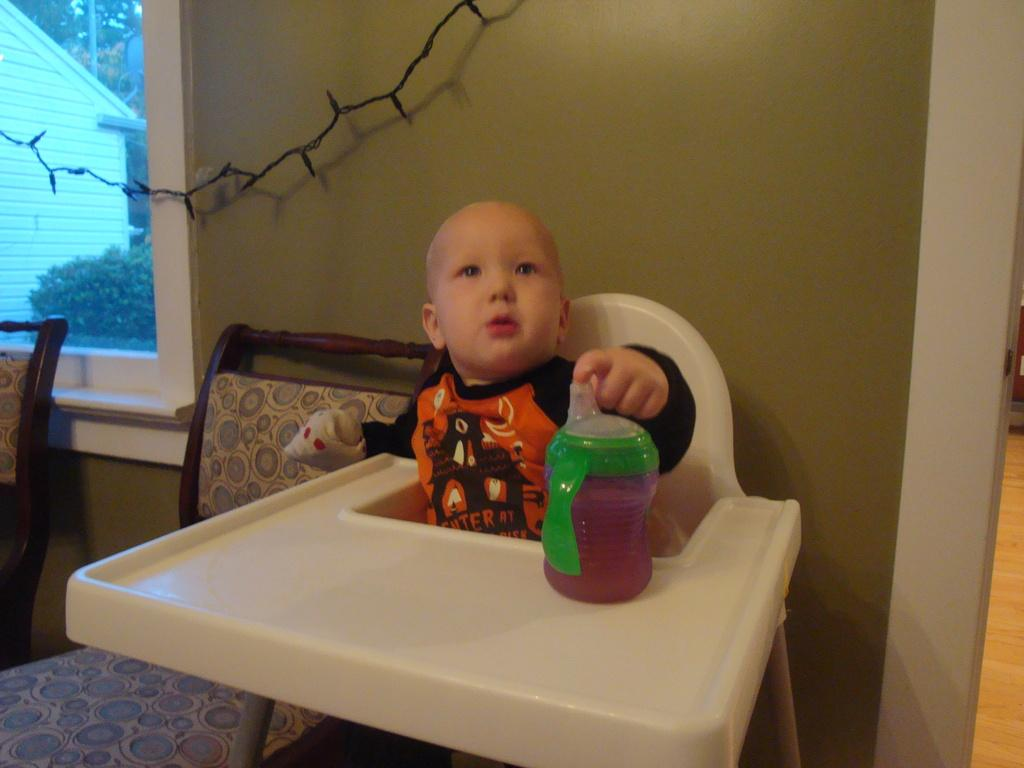What is the baby doing in the image? The baby is sitting on a chair in the image. What is in front of the baby? There is a bottle in front of the baby. What can be seen through the window in the room? Plants and a house are visible outside the window. How many chairs are beside the baby? There are 2 chairs beside the baby. What type of police wing is visible outside the window? There is no police wing visible outside the window; the image only shows plants and a house. 